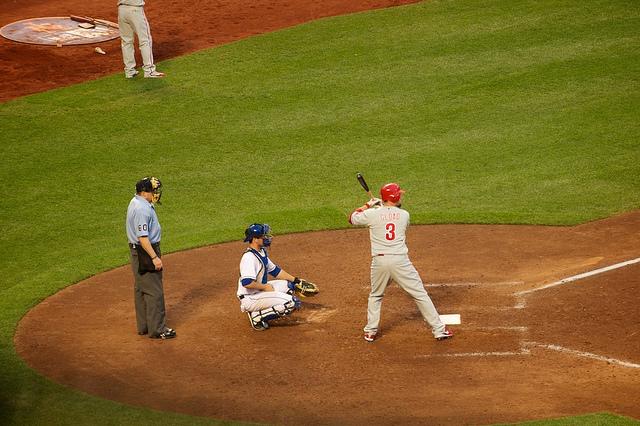What is the man behind the catcher called?
Concise answer only. Umpire. What sport is being played?
Give a very brief answer. Baseball. What color is the batter's helmet?
Quick response, please. Red. 